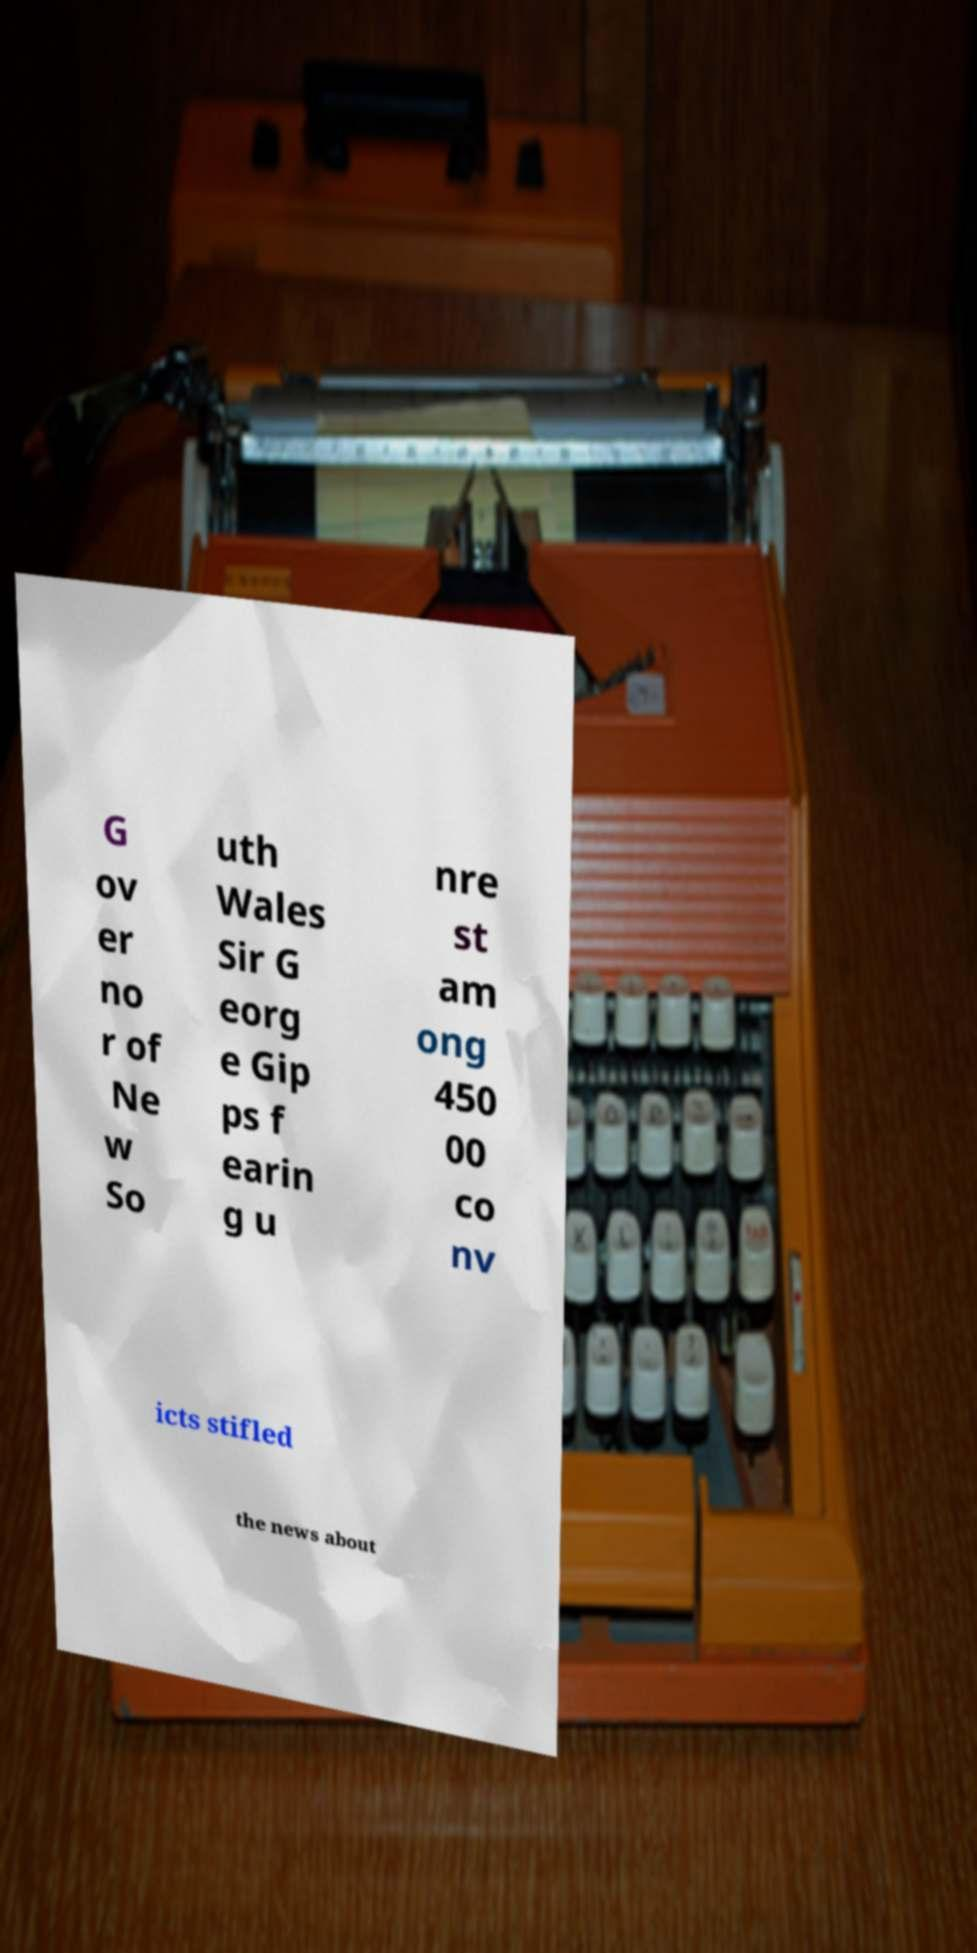There's text embedded in this image that I need extracted. Can you transcribe it verbatim? G ov er no r of Ne w So uth Wales Sir G eorg e Gip ps f earin g u nre st am ong 450 00 co nv icts stifled the news about 